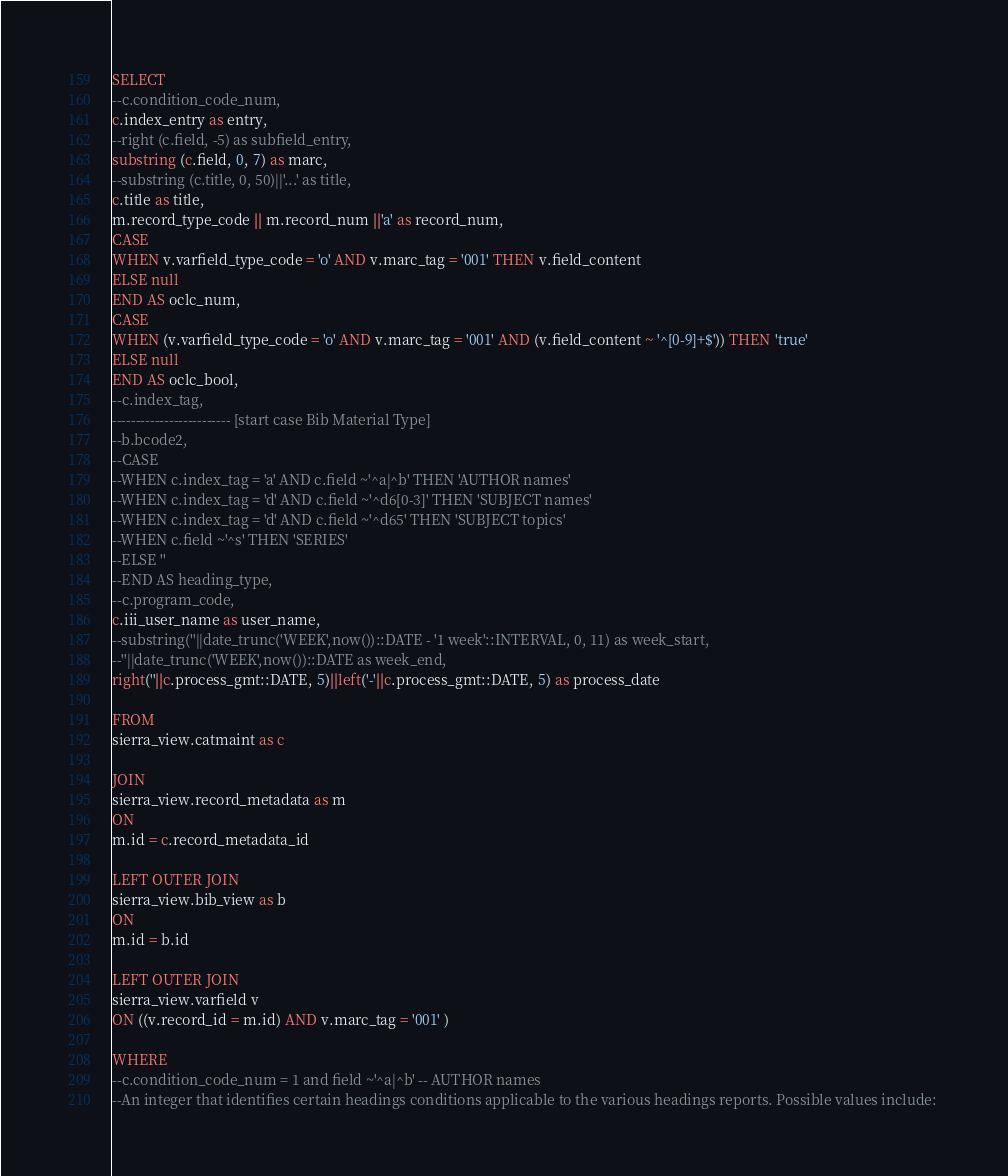<code> <loc_0><loc_0><loc_500><loc_500><_SQL_>SELECT
--c.condition_code_num,
c.index_entry as entry,
--right (c.field, -5) as subfield_entry,
substring (c.field, 0, 7) as marc,
--substring (c.title, 0, 50)||'...' as title,
c.title as title,
m.record_type_code || m.record_num ||'a' as record_num,
CASE
WHEN v.varfield_type_code = 'o' AND v.marc_tag = '001' THEN v.field_content
ELSE null
END AS oclc_num,
CASE
WHEN (v.varfield_type_code = 'o' AND v.marc_tag = '001' AND (v.field_content ~ '^[0-9]+$')) THEN 'true'
ELSE null
END AS oclc_bool,
--c.index_tag,
------------------------- [start case Bib Material Type]
--b.bcode2,
--CASE
--WHEN c.index_tag = 'a' AND c.field ~'^a|^b' THEN 'AUTHOR names'
--WHEN c.index_tag = 'd' AND c.field ~'^d6[0-3]' THEN 'SUBJECT names'
--WHEN c.index_tag = 'd' AND c.field ~'^d65' THEN 'SUBJECT topics'
--WHEN c.field ~'^s' THEN 'SERIES'
--ELSE ''
--END AS heading_type,
--c.program_code,
c.iii_user_name as user_name,
--substring(''||date_trunc('WEEK',now())::DATE - '1 week'::INTERVAL, 0, 11) as week_start,
--''||date_trunc('WEEK',now())::DATE as week_end,
right(''||c.process_gmt::DATE, 5)||left('-'||c.process_gmt::DATE, 5) as process_date

FROM
sierra_view.catmaint as c

JOIN
sierra_view.record_metadata as m
ON
m.id = c.record_metadata_id

LEFT OUTER JOIN
sierra_view.bib_view as b
ON
m.id = b.id

LEFT OUTER JOIN
sierra_view.varfield v
ON ((v.record_id = m.id) AND v.marc_tag = '001' )

WHERE
--c.condition_code_num = 1 and field ~'^a|^b' -- AUTHOR names
--An integer that identifies certain headings conditions applicable to the various headings reports. Possible values include: </code> 